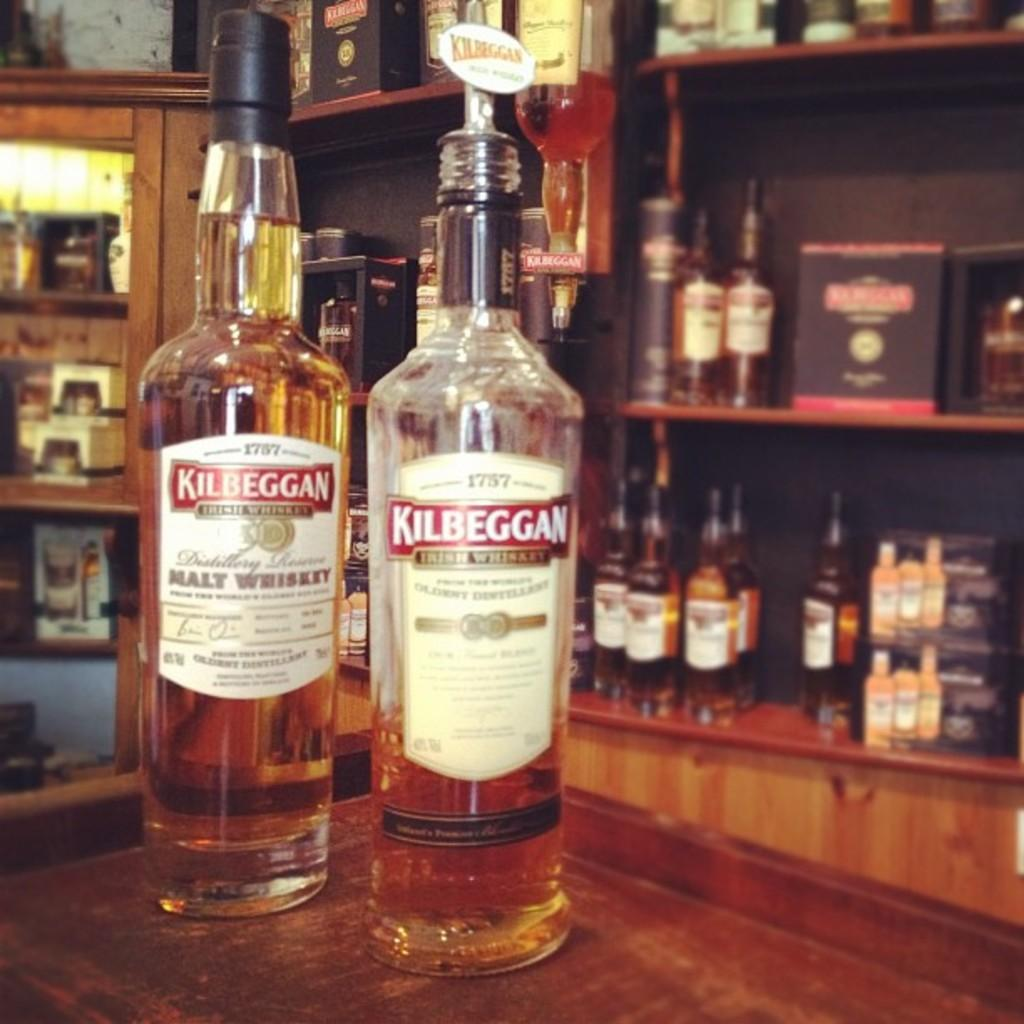How many bottles are visible on the table in the image? There are two bottles on the table in the image. What can be seen on the bottles? The bottles have labels on them. What is visible in the background of the image? There are cupboards with many bottles in the background. What type of plantation can be seen in the background of the image? There is no plantation present in the image; it features a table with two bottles and cupboards with many bottles in the background. Can you hear a drum playing in the image? There is no sound or indication of a drum in the image. 